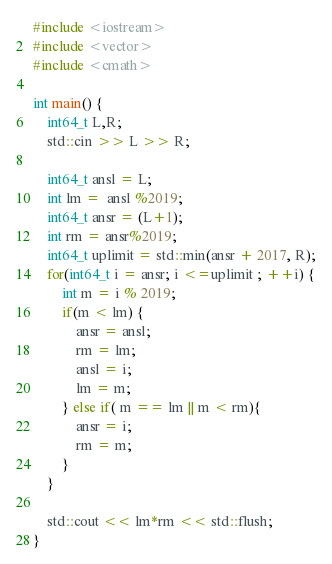Convert code to text. <code><loc_0><loc_0><loc_500><loc_500><_C++_>#include <iostream>
#include <vector>
#include <cmath>

int main() {
    int64_t L,R;
    std::cin >> L >> R;
    
    int64_t ansl = L;
    int lm =  ansl %2019;
    int64_t ansr = (L+1);
    int rm = ansr%2019;
  	int64_t uplimit = std::min(ansr + 2017, R);
    for(int64_t i = ansr; i <=uplimit ; ++i) {
        int m = i % 2019;
        if(m < lm) {
            ansr = ansl;
            rm = lm;
            ansl = i;
            lm = m;
        } else if( m == lm || m < rm){
            ansr = i;
            rm = m;
        }
    }
    
    std::cout << lm*rm << std::flush;
}</code> 